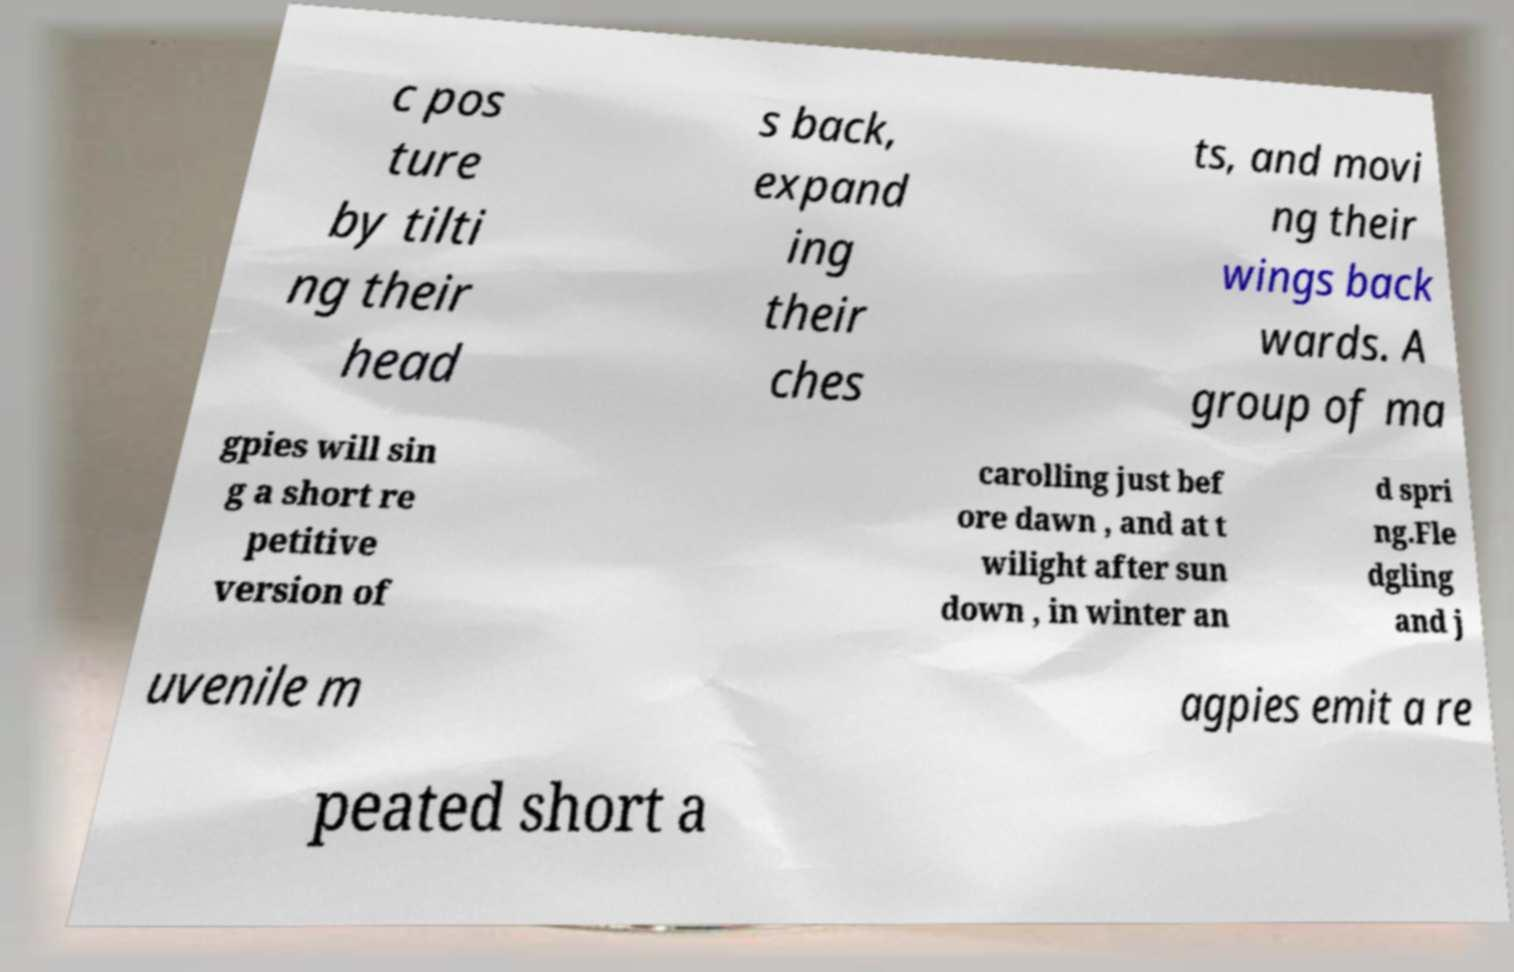Can you accurately transcribe the text from the provided image for me? c pos ture by tilti ng their head s back, expand ing their ches ts, and movi ng their wings back wards. A group of ma gpies will sin g a short re petitive version of carolling just bef ore dawn , and at t wilight after sun down , in winter an d spri ng.Fle dgling and j uvenile m agpies emit a re peated short a 